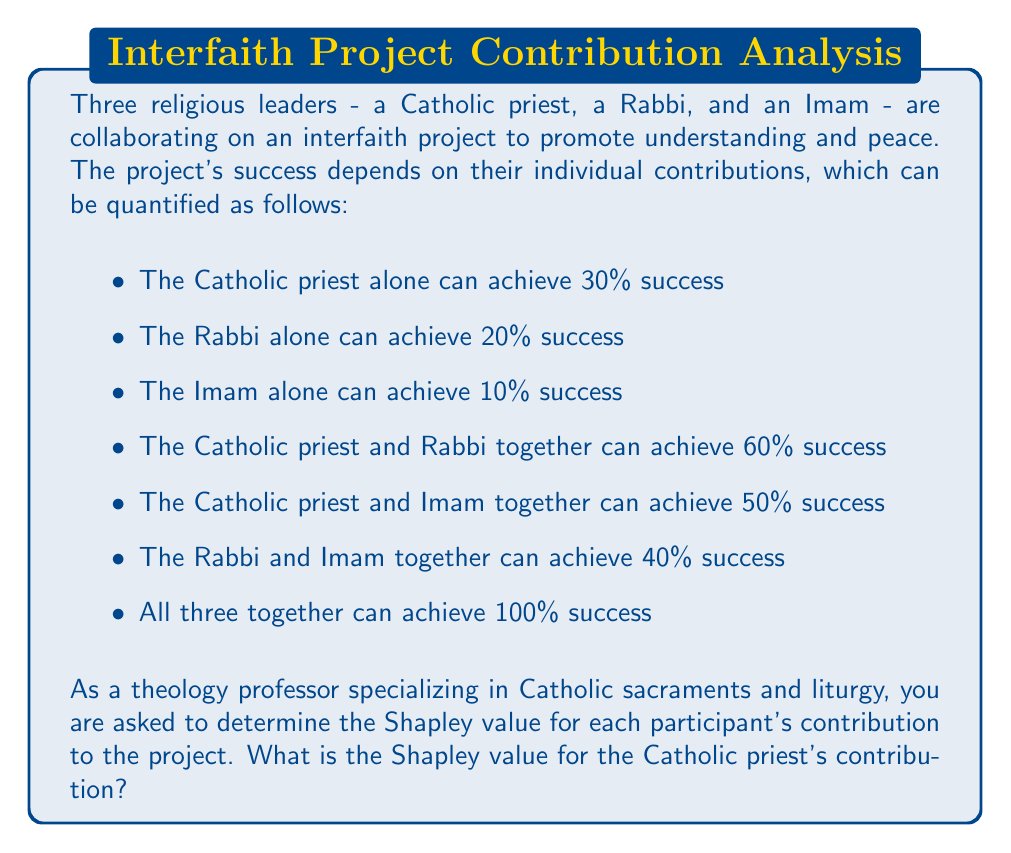Solve this math problem. To determine the Shapley value for the Catholic priest's contribution, we need to calculate the average marginal contribution of the priest across all possible coalition formations. Let's break this down step-by-step:

1. First, list all possible coalition formations:
   (P), (R), (I), (P,R), (P,I), (R,I), (P,R,I)
   Where P = Priest, R = Rabbi, I = Imam

2. Calculate the marginal contribution of the priest in each formation:

   a) (P) = 30%
   b) (P,R) - (R) = 60% - 20% = 40%
   c) (P,I) - (I) = 50% - 10% = 40%
   d) (P,R,I) - (R,I) = 100% - 40% = 60%

3. The Shapley value is the average of these marginal contributions, considering all possible orderings:

   There are 3! = 6 possible orderings:
   (P,R,I), (P,I,R), (R,P,I), (R,I,P), (I,P,R), (I,R,P)

   Calculating the priest's contribution in each ordering:
   (P,R,I): 30%
   (P,I,R): 30%
   (R,P,I): 40%
   (R,I,P): 60%
   (I,P,R): 40%
   (I,R,P): 60%

4. The Shapley value is the average of these contributions:

   $$ \text{Shapley Value} = \frac{30\% + 30\% + 40\% + 60\% + 40\% + 60\%}{6} = \frac{260\%}{6} = 43.33\% $$

Therefore, the Shapley value for the Catholic priest's contribution is approximately 43.33%.
Answer: The Shapley value for the Catholic priest's contribution is 43.33%. 